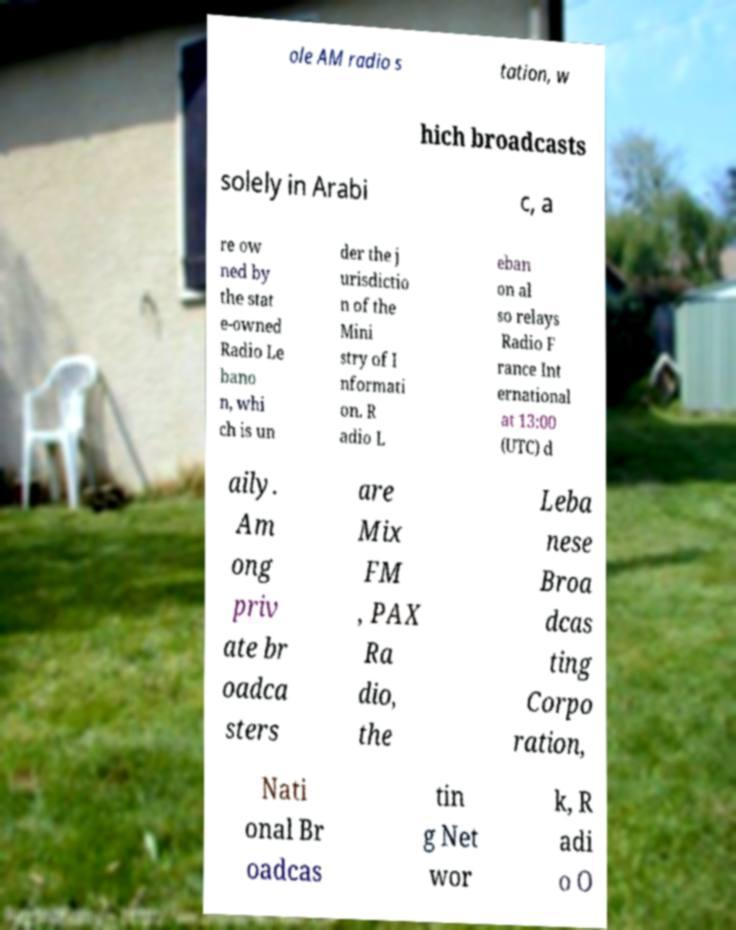Can you accurately transcribe the text from the provided image for me? ole AM radio s tation, w hich broadcasts solely in Arabi c, a re ow ned by the stat e-owned Radio Le bano n, whi ch is un der the j urisdictio n of the Mini stry of I nformati on. R adio L eban on al so relays Radio F rance Int ernational at 13:00 (UTC) d aily. Am ong priv ate br oadca sters are Mix FM , PAX Ra dio, the Leba nese Broa dcas ting Corpo ration, Nati onal Br oadcas tin g Net wor k, R adi o O 